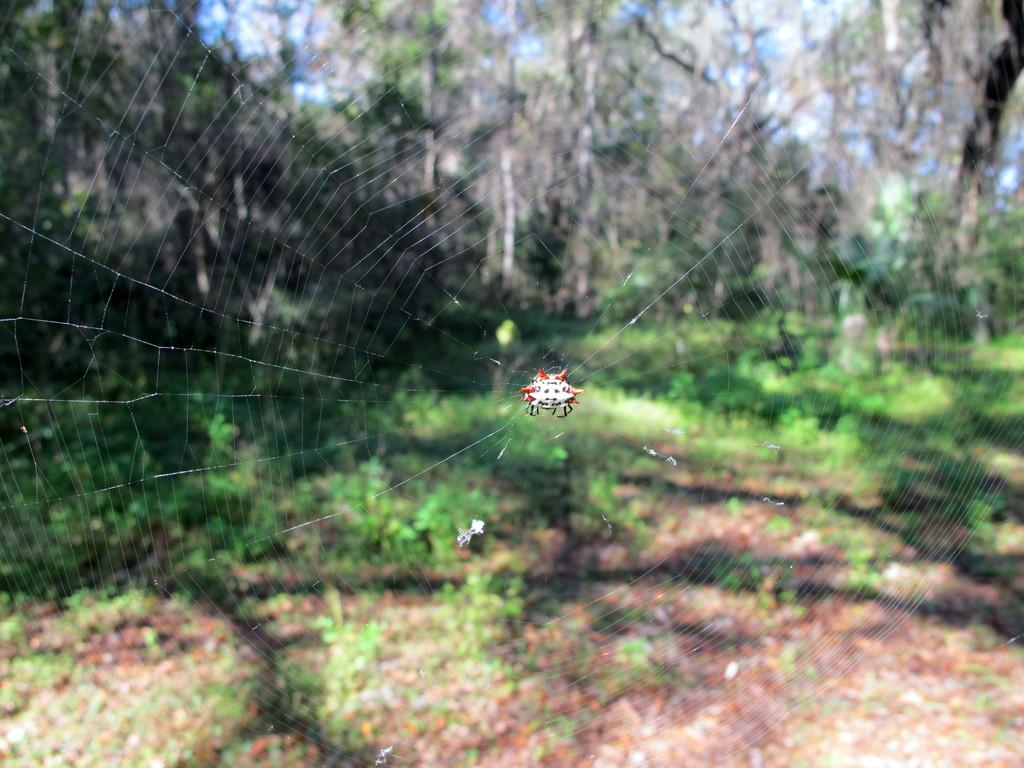What is the main subject of the picture? The main subject of the picture is a spider. What is the spider doing in the image? The spider is building its web. What type of surface is visible at the bottom of the image? There is soil visible at the bottom of the image. What type of plants can be seen in the image? There are herbs in the image. What can be seen in the background of the image? Trees and herbs are present in the background of the image. Can you see any quicksand in the image? No, there is no quicksand present in the image. Is there a band playing music in the background of the image? No, there is no band present in the image. 